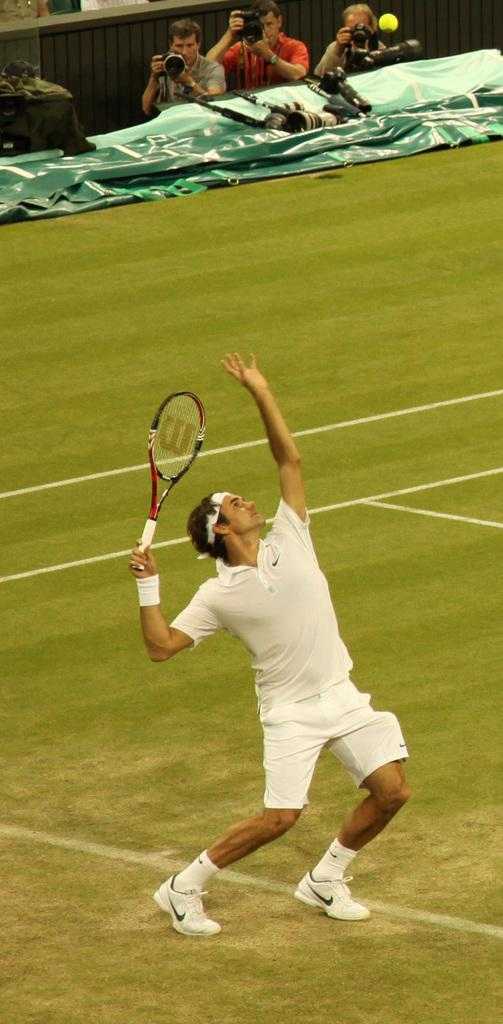What is the man in the image doing? The man is playing tennis in the image. What object is the man holding while playing tennis? The man is holding a tennis racket. What are the three persons in the background of the image doing? The three persons in the background are taking pictures. What are they using to take pictures? They are holding cameras. What color is the shirt the man is wearing while playing tennis in the image? The provided facts do not mention the color of the man's shirt, so we cannot determine the color of his shirt from the image. 